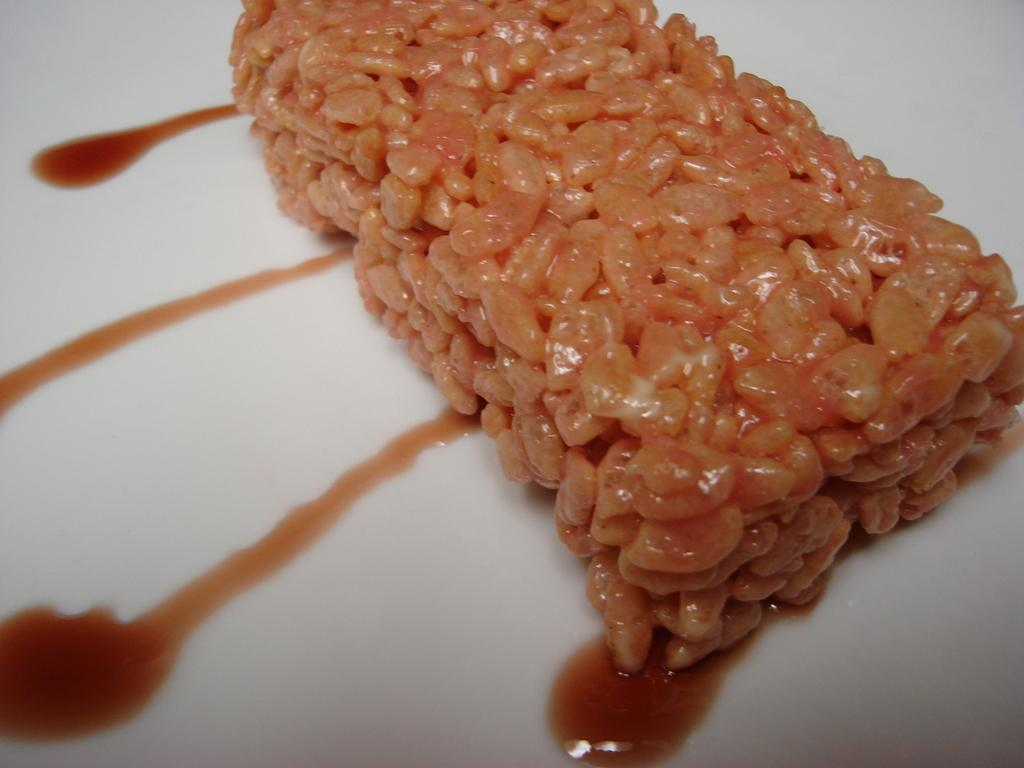What type of objects can be seen in the image? There are food items in the image. What is the color of the object on which the food items are placed? The food items are on a white-colored object. What type of mitten can be seen in the image? There is no mitten present in the image. What boundary is visible in the image? There is no boundary visible in the image. 